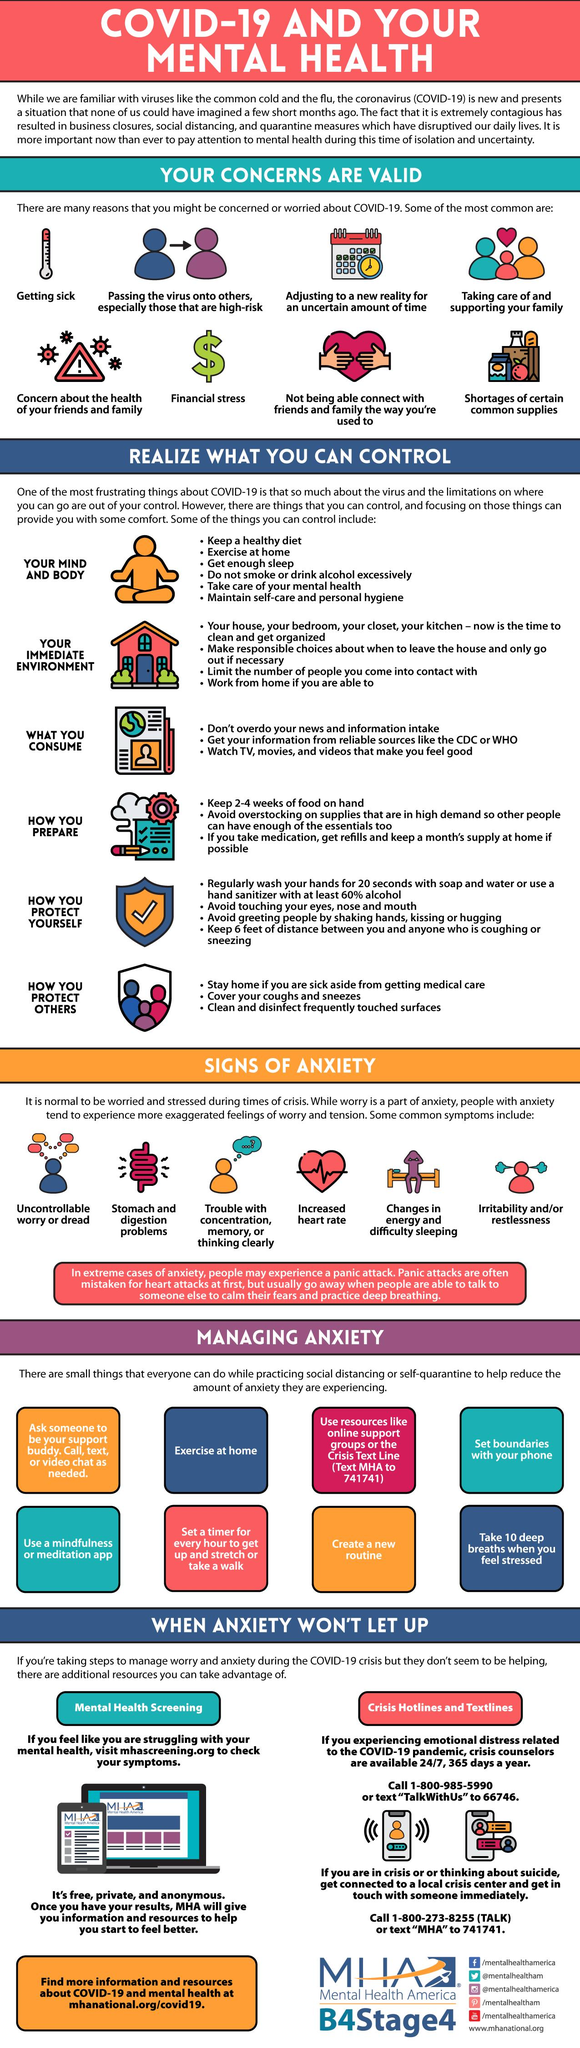Highlight a few significant elements in this photo. Additional resources available for managing anxiety when anxiety persists include mental health screening, crisis hotlines and textlines. The number of factors that can be controlled is six, as demonstrated in the shown examples. Eight reasons have been demonstrated. The use of the dollar sign is a clear indication of financial stress. The concern shown by a thermometer is getting sick. 